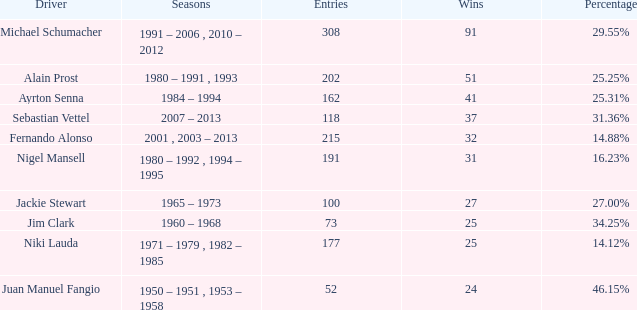Which operator has under 37 wins and at 1 177.0. 